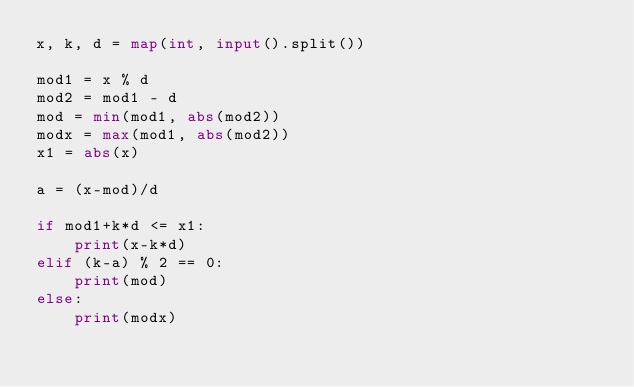<code> <loc_0><loc_0><loc_500><loc_500><_Python_>x, k, d = map(int, input().split())

mod1 = x % d
mod2 = mod1 - d
mod = min(mod1, abs(mod2))
modx = max(mod1, abs(mod2))
x1 = abs(x)

a = (x-mod)/d

if mod1+k*d <= x1:
    print(x-k*d)
elif (k-a) % 2 == 0:
    print(mod)
else:
    print(modx)
</code> 